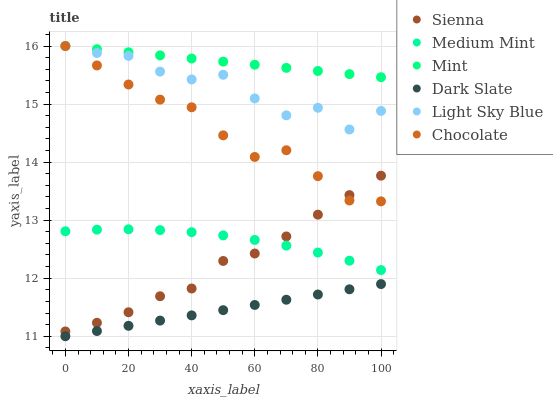Does Dark Slate have the minimum area under the curve?
Answer yes or no. Yes. Does Mint have the maximum area under the curve?
Answer yes or no. Yes. Does Chocolate have the minimum area under the curve?
Answer yes or no. No. Does Chocolate have the maximum area under the curve?
Answer yes or no. No. Is Dark Slate the smoothest?
Answer yes or no. Yes. Is Light Sky Blue the roughest?
Answer yes or no. Yes. Is Chocolate the smoothest?
Answer yes or no. No. Is Chocolate the roughest?
Answer yes or no. No. Does Dark Slate have the lowest value?
Answer yes or no. Yes. Does Chocolate have the lowest value?
Answer yes or no. No. Does Mint have the highest value?
Answer yes or no. Yes. Does Sienna have the highest value?
Answer yes or no. No. Is Dark Slate less than Light Sky Blue?
Answer yes or no. Yes. Is Chocolate greater than Dark Slate?
Answer yes or no. Yes. Does Chocolate intersect Mint?
Answer yes or no. Yes. Is Chocolate less than Mint?
Answer yes or no. No. Is Chocolate greater than Mint?
Answer yes or no. No. Does Dark Slate intersect Light Sky Blue?
Answer yes or no. No. 